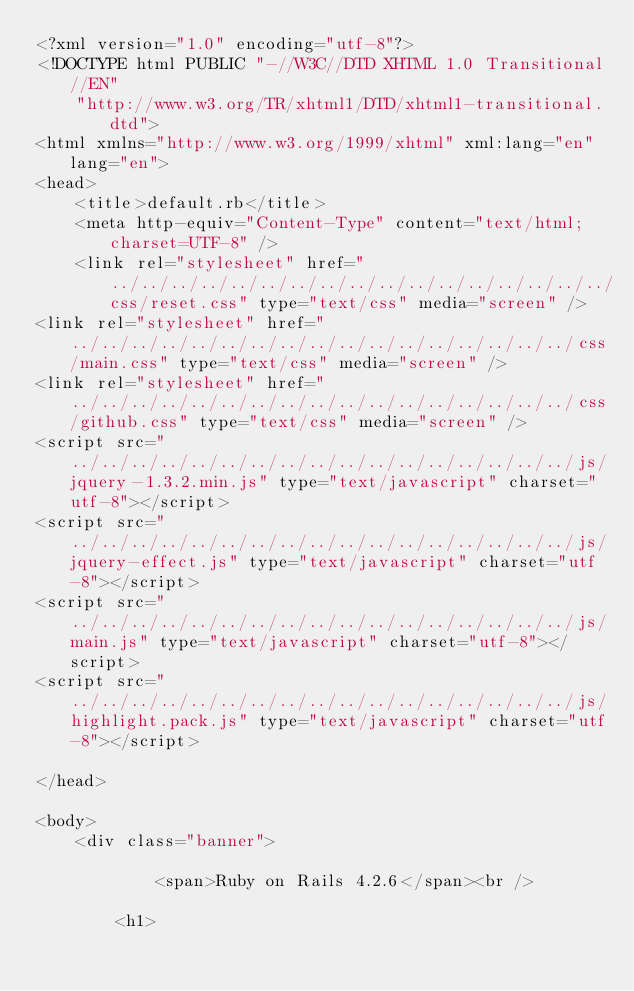<code> <loc_0><loc_0><loc_500><loc_500><_HTML_><?xml version="1.0" encoding="utf-8"?>
<!DOCTYPE html PUBLIC "-//W3C//DTD XHTML 1.0 Transitional//EN"
    "http://www.w3.org/TR/xhtml1/DTD/xhtml1-transitional.dtd">
<html xmlns="http://www.w3.org/1999/xhtml" xml:lang="en" lang="en">
<head>
    <title>default.rb</title>
    <meta http-equiv="Content-Type" content="text/html; charset=UTF-8" />
    <link rel="stylesheet" href="../../../../../../../../../../../../../../../../../css/reset.css" type="text/css" media="screen" />
<link rel="stylesheet" href="../../../../../../../../../../../../../../../../../css/main.css" type="text/css" media="screen" />
<link rel="stylesheet" href="../../../../../../../../../../../../../../../../../css/github.css" type="text/css" media="screen" />
<script src="../../../../../../../../../../../../../../../../../js/jquery-1.3.2.min.js" type="text/javascript" charset="utf-8"></script>
<script src="../../../../../../../../../../../../../../../../../js/jquery-effect.js" type="text/javascript" charset="utf-8"></script>
<script src="../../../../../../../../../../../../../../../../../js/main.js" type="text/javascript" charset="utf-8"></script>
<script src="../../../../../../../../../../../../../../../../../js/highlight.pack.js" type="text/javascript" charset="utf-8"></script>

</head>

<body>     
    <div class="banner">
        
            <span>Ruby on Rails 4.2.6</span><br />
        
        <h1></code> 